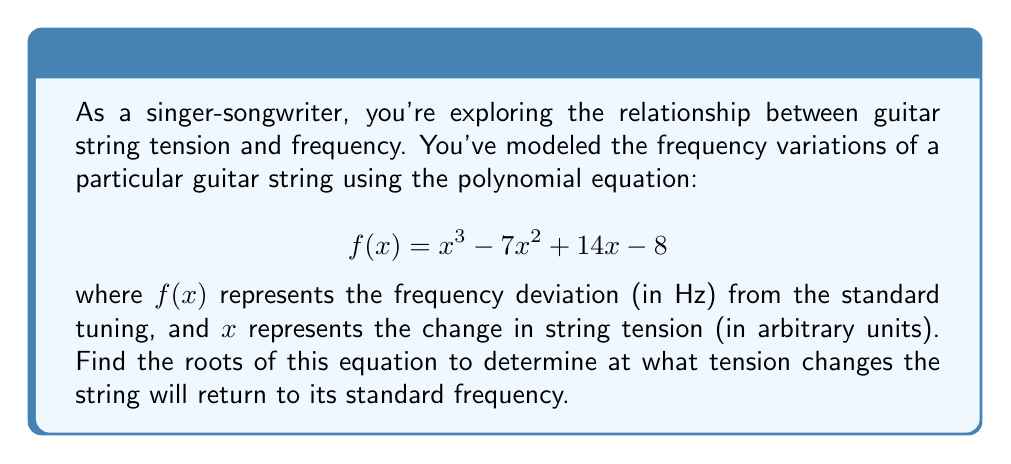Teach me how to tackle this problem. To find the roots of the polynomial equation, we need to solve $f(x) = 0$. Let's approach this step-by-step:

1) We start with the equation: $x^3 - 7x^2 + 14x - 8 = 0$

2) This is a cubic equation. One way to solve it is to guess one root and then use polynomial long division to reduce it to a quadratic equation.

3) By inspection or trial and error, we can find that $x = 1$ is a root. (When $x = 1$, $f(1) = 1^3 - 7(1)^2 + 14(1) - 8 = 1 - 7 + 14 - 8 = 0$)

4) Using polynomial long division with $(x - 1)$:

   $x^3 - 7x^2 + 14x - 8 = (x - 1)(x^2 - 6x + 8)$

5) Now we have reduced it to solving: $x^2 - 6x + 8 = 0$

6) This is a quadratic equation. We can solve it using the quadratic formula: $x = \frac{-b \pm \sqrt{b^2 - 4ac}}{2a}$

   Where $a = 1$, $b = -6$, and $c = 8$

7) Plugging into the formula:

   $x = \frac{6 \pm \sqrt{36 - 32}}{2} = \frac{6 \pm \sqrt{4}}{2} = \frac{6 \pm 2}{2}$

8) This gives us two more roots:

   $x = \frac{6 + 2}{2} = 4$ and $x = \frac{6 - 2}{2} = 2$

Therefore, the three roots of the equation are 1, 2, and 4.
Answer: $x = 1$, $x = 2$, and $x = 4$ 